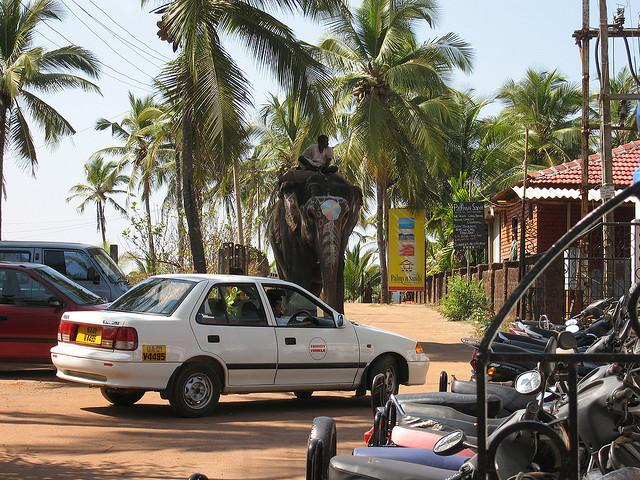What is this place?

Choices:
A) car dealer
B) subway
C) biker bar
D) walmart biker bar 